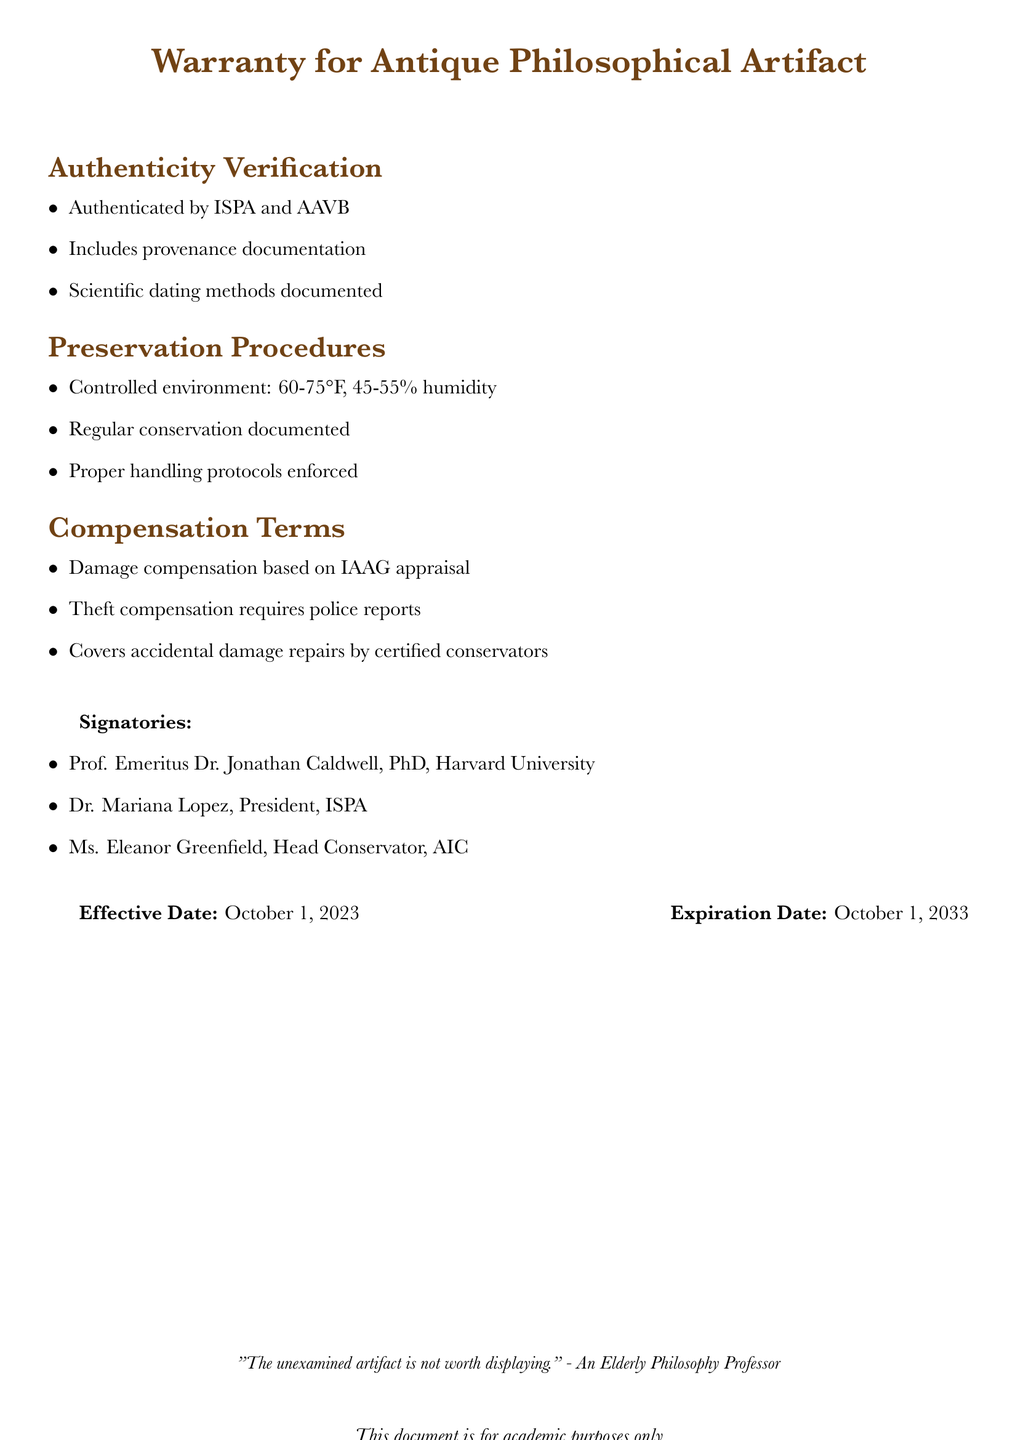What is the effective date of the warranty? The effective date is explicitly stated in the document and is October 1, 2023.
Answer: October 1, 2023 Who authenticated the artifact? The document lists ISPA and AAVB as the entities responsible for authentication.
Answer: ISPA and AAVB What temperature range is required for preservation? The document specifies a temperature range of 60-75°F for preservation procedures.
Answer: 60-75°F What is required for theft compensation? The document mentions that theft compensation requires police reports to process the claim.
Answer: Police reports Who is the head conservator mentioned in the document? The document provides the name of the head conservator, which is Eleanor Greenfield.
Answer: Eleanor Greenfield What type of damage does the compensation cover? The document states that accidental damage repairs by certified conservators are covered under compensation terms.
Answer: Accidental damage repairs What is the expiration date of the warranty? The expiration date is clearly stated in the document, which is October 1, 2033.
Answer: October 1, 2033 What must be documented according to preservation procedures? The document specifies that regular conservation must be documented as part of the preservation procedures.
Answer: Regular conservation documented Who signed the warranty document? The document includes three signatories who are responsible for the warranty, including Prof. Emeritus Dr. Jonathan Caldwell.
Answer: Prof. Emeritus Dr. Jonathan Caldwell, PhD, Harvard University 